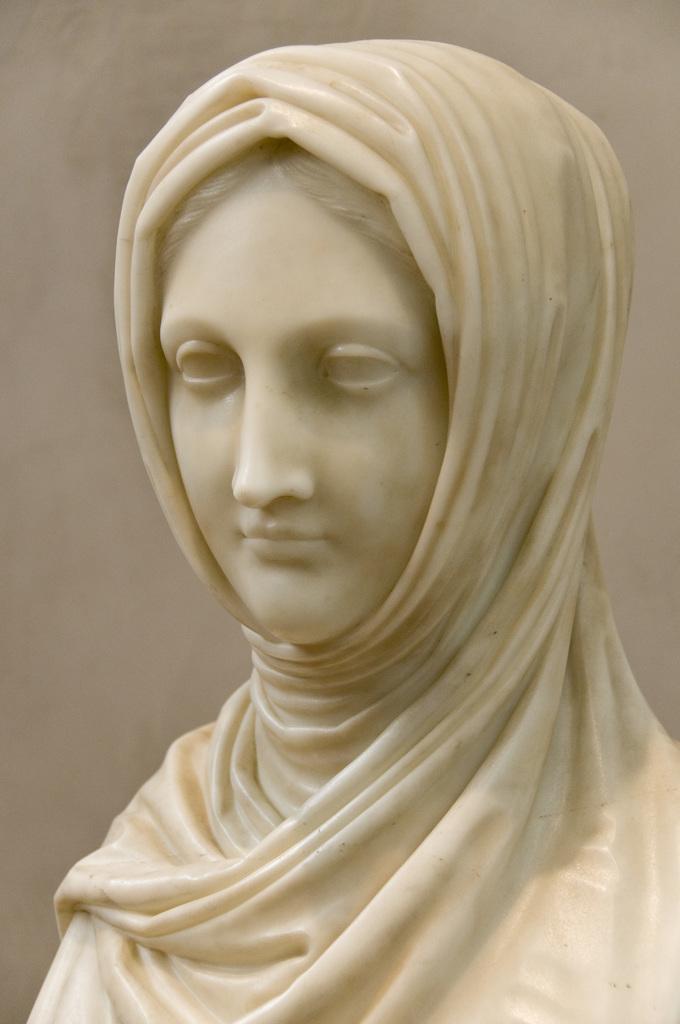Can you describe this image briefly? In the image there is a sculpture of a woman. 